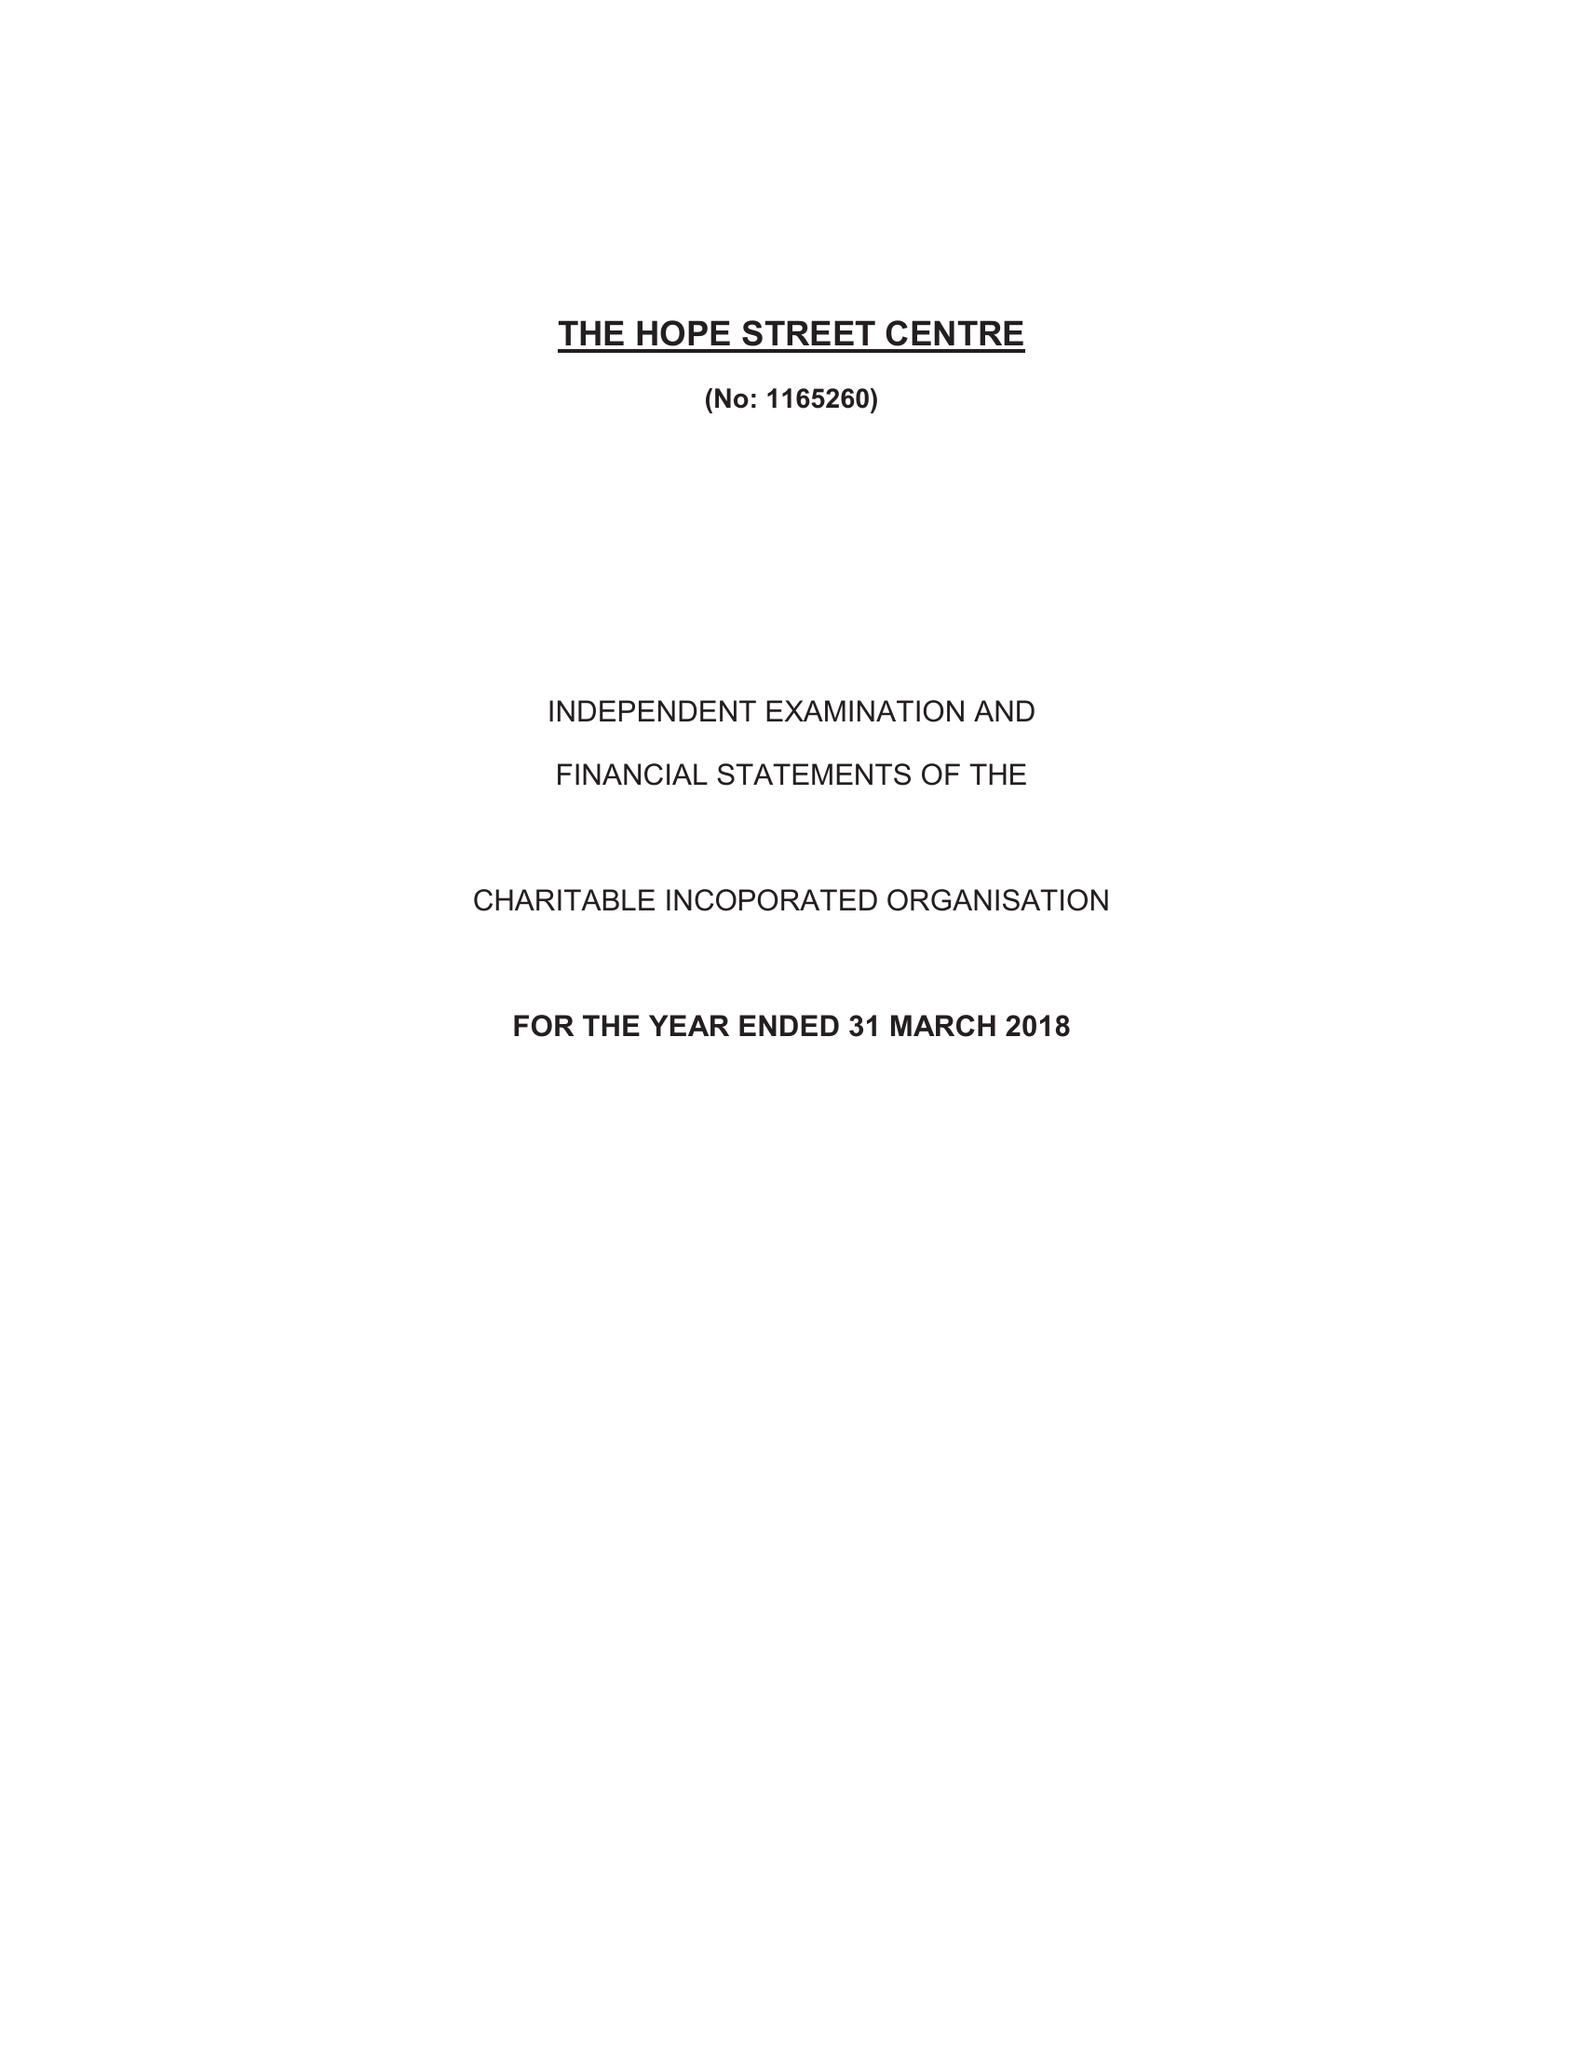What is the value for the address__street_line?
Answer the question using a single word or phrase. ROSE STREET 